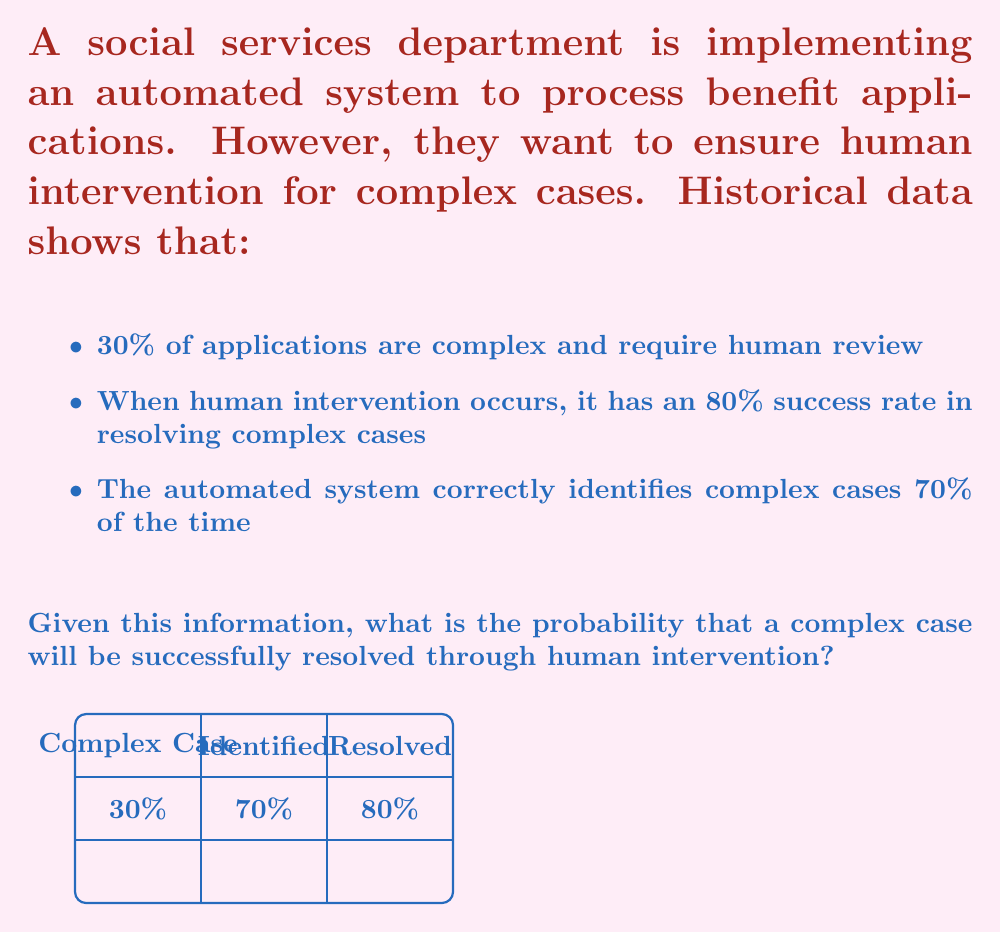What is the answer to this math problem? To solve this problem, we'll use Bayes' theorem and the law of total probability. Let's define our events:

A: The case is complex
B: The case is identified as complex
C: The case is successfully resolved

We want to find $P(C|A)$, the probability of successful resolution given that the case is complex.

Step 1: Use the law of total probability
$$P(C|A) = P(C|A,B)P(B|A) + P(C|A,B^c)P(B^c|A)$$

Step 2: Identify the given probabilities
$P(A) = 0.30$ (30% of cases are complex)
$P(B|A) = 0.70$ (70% of complex cases are correctly identified)
$P(C|A,B) = 0.80$ (80% success rate when human intervention occurs)

Step 3: Calculate $P(B^c|A)$
$P(B^c|A) = 1 - P(B|A) = 1 - 0.70 = 0.30$

Step 4: Determine $P(C|A,B^c)$
When a complex case is not identified, there's no human intervention, so $P(C|A,B^c) = 0$

Step 5: Apply the formula
$$P(C|A) = (0.80 * 0.70) + (0 * 0.30) = 0.56$$

Therefore, the probability that a complex case will be successfully resolved through human intervention is 0.56 or 56%.
Answer: $0.56$ or $56\%$ 